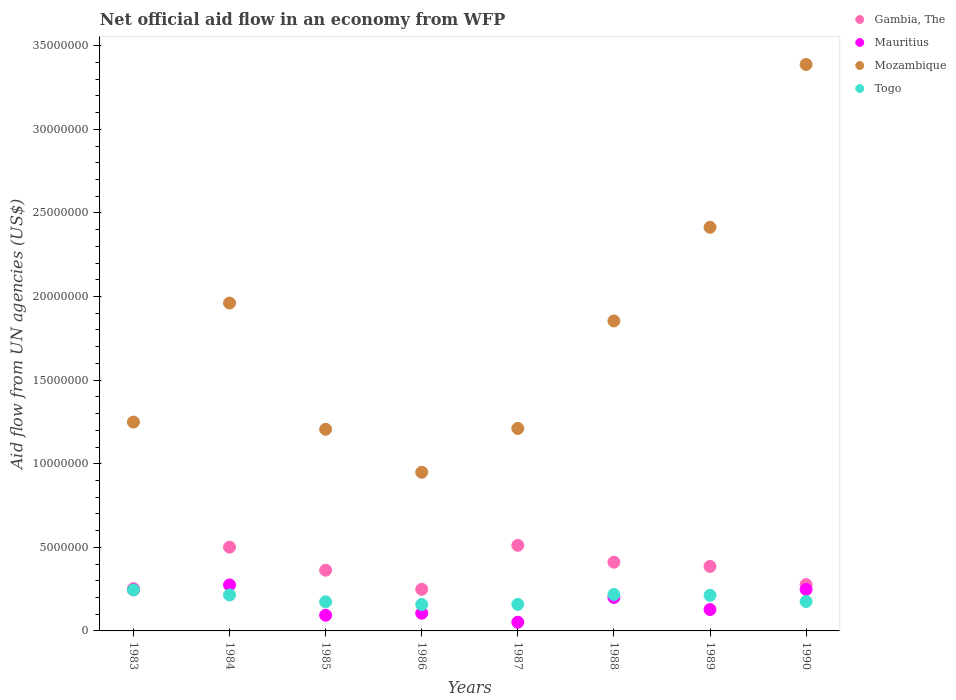What is the net official aid flow in Togo in 1988?
Your answer should be very brief. 2.18e+06. Across all years, what is the maximum net official aid flow in Togo?
Provide a short and direct response. 2.45e+06. Across all years, what is the minimum net official aid flow in Gambia, The?
Provide a short and direct response. 2.49e+06. In which year was the net official aid flow in Mozambique maximum?
Offer a very short reply. 1990. What is the total net official aid flow in Gambia, The in the graph?
Keep it short and to the point. 2.95e+07. What is the difference between the net official aid flow in Gambia, The in 1983 and that in 1987?
Provide a succinct answer. -2.59e+06. What is the difference between the net official aid flow in Gambia, The in 1988 and the net official aid flow in Mozambique in 1986?
Ensure brevity in your answer.  -5.38e+06. What is the average net official aid flow in Mauritius per year?
Give a very brief answer. 1.69e+06. In the year 1989, what is the difference between the net official aid flow in Mauritius and net official aid flow in Togo?
Your answer should be compact. -8.50e+05. What is the ratio of the net official aid flow in Gambia, The in 1983 to that in 1989?
Your answer should be very brief. 0.66. Is the net official aid flow in Mozambique in 1983 less than that in 1986?
Offer a very short reply. No. What is the difference between the highest and the lowest net official aid flow in Togo?
Your response must be concise. 8.70e+05. Is the sum of the net official aid flow in Gambia, The in 1985 and 1986 greater than the maximum net official aid flow in Togo across all years?
Your answer should be very brief. Yes. Does the net official aid flow in Togo monotonically increase over the years?
Offer a terse response. No. Are the values on the major ticks of Y-axis written in scientific E-notation?
Offer a very short reply. No. Does the graph contain grids?
Provide a short and direct response. No. Where does the legend appear in the graph?
Your answer should be compact. Top right. How many legend labels are there?
Provide a short and direct response. 4. What is the title of the graph?
Keep it short and to the point. Net official aid flow in an economy from WFP. What is the label or title of the Y-axis?
Offer a very short reply. Aid flow from UN agencies (US$). What is the Aid flow from UN agencies (US$) of Gambia, The in 1983?
Offer a terse response. 2.53e+06. What is the Aid flow from UN agencies (US$) of Mauritius in 1983?
Offer a terse response. 2.46e+06. What is the Aid flow from UN agencies (US$) of Mozambique in 1983?
Provide a short and direct response. 1.25e+07. What is the Aid flow from UN agencies (US$) of Togo in 1983?
Your response must be concise. 2.45e+06. What is the Aid flow from UN agencies (US$) in Gambia, The in 1984?
Your answer should be very brief. 5.01e+06. What is the Aid flow from UN agencies (US$) in Mauritius in 1984?
Ensure brevity in your answer.  2.75e+06. What is the Aid flow from UN agencies (US$) of Mozambique in 1984?
Your answer should be compact. 1.96e+07. What is the Aid flow from UN agencies (US$) of Togo in 1984?
Provide a short and direct response. 2.15e+06. What is the Aid flow from UN agencies (US$) of Gambia, The in 1985?
Ensure brevity in your answer.  3.63e+06. What is the Aid flow from UN agencies (US$) of Mauritius in 1985?
Provide a succinct answer. 9.40e+05. What is the Aid flow from UN agencies (US$) of Mozambique in 1985?
Your answer should be very brief. 1.21e+07. What is the Aid flow from UN agencies (US$) of Togo in 1985?
Your answer should be very brief. 1.74e+06. What is the Aid flow from UN agencies (US$) in Gambia, The in 1986?
Make the answer very short. 2.49e+06. What is the Aid flow from UN agencies (US$) of Mauritius in 1986?
Your answer should be very brief. 1.06e+06. What is the Aid flow from UN agencies (US$) in Mozambique in 1986?
Offer a very short reply. 9.49e+06. What is the Aid flow from UN agencies (US$) of Togo in 1986?
Make the answer very short. 1.58e+06. What is the Aid flow from UN agencies (US$) in Gambia, The in 1987?
Ensure brevity in your answer.  5.12e+06. What is the Aid flow from UN agencies (US$) in Mauritius in 1987?
Offer a terse response. 5.20e+05. What is the Aid flow from UN agencies (US$) in Mozambique in 1987?
Give a very brief answer. 1.21e+07. What is the Aid flow from UN agencies (US$) of Togo in 1987?
Keep it short and to the point. 1.59e+06. What is the Aid flow from UN agencies (US$) of Gambia, The in 1988?
Ensure brevity in your answer.  4.11e+06. What is the Aid flow from UN agencies (US$) of Mozambique in 1988?
Your answer should be very brief. 1.85e+07. What is the Aid flow from UN agencies (US$) in Togo in 1988?
Give a very brief answer. 2.18e+06. What is the Aid flow from UN agencies (US$) of Gambia, The in 1989?
Make the answer very short. 3.86e+06. What is the Aid flow from UN agencies (US$) of Mauritius in 1989?
Provide a short and direct response. 1.28e+06. What is the Aid flow from UN agencies (US$) in Mozambique in 1989?
Offer a very short reply. 2.41e+07. What is the Aid flow from UN agencies (US$) of Togo in 1989?
Give a very brief answer. 2.13e+06. What is the Aid flow from UN agencies (US$) in Gambia, The in 1990?
Make the answer very short. 2.77e+06. What is the Aid flow from UN agencies (US$) in Mauritius in 1990?
Provide a short and direct response. 2.48e+06. What is the Aid flow from UN agencies (US$) of Mozambique in 1990?
Provide a short and direct response. 3.39e+07. What is the Aid flow from UN agencies (US$) of Togo in 1990?
Provide a short and direct response. 1.76e+06. Across all years, what is the maximum Aid flow from UN agencies (US$) of Gambia, The?
Offer a very short reply. 5.12e+06. Across all years, what is the maximum Aid flow from UN agencies (US$) in Mauritius?
Your response must be concise. 2.75e+06. Across all years, what is the maximum Aid flow from UN agencies (US$) of Mozambique?
Make the answer very short. 3.39e+07. Across all years, what is the maximum Aid flow from UN agencies (US$) of Togo?
Provide a short and direct response. 2.45e+06. Across all years, what is the minimum Aid flow from UN agencies (US$) in Gambia, The?
Provide a succinct answer. 2.49e+06. Across all years, what is the minimum Aid flow from UN agencies (US$) in Mauritius?
Give a very brief answer. 5.20e+05. Across all years, what is the minimum Aid flow from UN agencies (US$) in Mozambique?
Give a very brief answer. 9.49e+06. Across all years, what is the minimum Aid flow from UN agencies (US$) of Togo?
Your answer should be compact. 1.58e+06. What is the total Aid flow from UN agencies (US$) in Gambia, The in the graph?
Make the answer very short. 2.95e+07. What is the total Aid flow from UN agencies (US$) in Mauritius in the graph?
Make the answer very short. 1.35e+07. What is the total Aid flow from UN agencies (US$) of Mozambique in the graph?
Offer a very short reply. 1.42e+08. What is the total Aid flow from UN agencies (US$) of Togo in the graph?
Offer a very short reply. 1.56e+07. What is the difference between the Aid flow from UN agencies (US$) of Gambia, The in 1983 and that in 1984?
Offer a terse response. -2.48e+06. What is the difference between the Aid flow from UN agencies (US$) of Mozambique in 1983 and that in 1984?
Offer a terse response. -7.12e+06. What is the difference between the Aid flow from UN agencies (US$) of Gambia, The in 1983 and that in 1985?
Offer a very short reply. -1.10e+06. What is the difference between the Aid flow from UN agencies (US$) in Mauritius in 1983 and that in 1985?
Your answer should be compact. 1.52e+06. What is the difference between the Aid flow from UN agencies (US$) of Mozambique in 1983 and that in 1985?
Give a very brief answer. 4.30e+05. What is the difference between the Aid flow from UN agencies (US$) of Togo in 1983 and that in 1985?
Provide a short and direct response. 7.10e+05. What is the difference between the Aid flow from UN agencies (US$) of Mauritius in 1983 and that in 1986?
Make the answer very short. 1.40e+06. What is the difference between the Aid flow from UN agencies (US$) of Mozambique in 1983 and that in 1986?
Give a very brief answer. 3.00e+06. What is the difference between the Aid flow from UN agencies (US$) in Togo in 1983 and that in 1986?
Your answer should be very brief. 8.70e+05. What is the difference between the Aid flow from UN agencies (US$) of Gambia, The in 1983 and that in 1987?
Your answer should be very brief. -2.59e+06. What is the difference between the Aid flow from UN agencies (US$) in Mauritius in 1983 and that in 1987?
Ensure brevity in your answer.  1.94e+06. What is the difference between the Aid flow from UN agencies (US$) in Mozambique in 1983 and that in 1987?
Offer a very short reply. 3.80e+05. What is the difference between the Aid flow from UN agencies (US$) in Togo in 1983 and that in 1987?
Make the answer very short. 8.60e+05. What is the difference between the Aid flow from UN agencies (US$) in Gambia, The in 1983 and that in 1988?
Offer a terse response. -1.58e+06. What is the difference between the Aid flow from UN agencies (US$) of Mauritius in 1983 and that in 1988?
Keep it short and to the point. 4.60e+05. What is the difference between the Aid flow from UN agencies (US$) in Mozambique in 1983 and that in 1988?
Your answer should be compact. -6.05e+06. What is the difference between the Aid flow from UN agencies (US$) in Gambia, The in 1983 and that in 1989?
Give a very brief answer. -1.33e+06. What is the difference between the Aid flow from UN agencies (US$) of Mauritius in 1983 and that in 1989?
Make the answer very short. 1.18e+06. What is the difference between the Aid flow from UN agencies (US$) in Mozambique in 1983 and that in 1989?
Offer a very short reply. -1.16e+07. What is the difference between the Aid flow from UN agencies (US$) of Togo in 1983 and that in 1989?
Your answer should be compact. 3.20e+05. What is the difference between the Aid flow from UN agencies (US$) of Gambia, The in 1983 and that in 1990?
Offer a terse response. -2.40e+05. What is the difference between the Aid flow from UN agencies (US$) of Mauritius in 1983 and that in 1990?
Make the answer very short. -2.00e+04. What is the difference between the Aid flow from UN agencies (US$) in Mozambique in 1983 and that in 1990?
Provide a short and direct response. -2.14e+07. What is the difference between the Aid flow from UN agencies (US$) in Togo in 1983 and that in 1990?
Your answer should be very brief. 6.90e+05. What is the difference between the Aid flow from UN agencies (US$) in Gambia, The in 1984 and that in 1985?
Provide a succinct answer. 1.38e+06. What is the difference between the Aid flow from UN agencies (US$) of Mauritius in 1984 and that in 1985?
Your response must be concise. 1.81e+06. What is the difference between the Aid flow from UN agencies (US$) in Mozambique in 1984 and that in 1985?
Your response must be concise. 7.55e+06. What is the difference between the Aid flow from UN agencies (US$) of Togo in 1984 and that in 1985?
Offer a terse response. 4.10e+05. What is the difference between the Aid flow from UN agencies (US$) of Gambia, The in 1984 and that in 1986?
Keep it short and to the point. 2.52e+06. What is the difference between the Aid flow from UN agencies (US$) of Mauritius in 1984 and that in 1986?
Your answer should be compact. 1.69e+06. What is the difference between the Aid flow from UN agencies (US$) in Mozambique in 1984 and that in 1986?
Make the answer very short. 1.01e+07. What is the difference between the Aid flow from UN agencies (US$) of Togo in 1984 and that in 1986?
Offer a terse response. 5.70e+05. What is the difference between the Aid flow from UN agencies (US$) of Mauritius in 1984 and that in 1987?
Provide a succinct answer. 2.23e+06. What is the difference between the Aid flow from UN agencies (US$) in Mozambique in 1984 and that in 1987?
Your answer should be very brief. 7.50e+06. What is the difference between the Aid flow from UN agencies (US$) of Togo in 1984 and that in 1987?
Provide a short and direct response. 5.60e+05. What is the difference between the Aid flow from UN agencies (US$) in Mauritius in 1984 and that in 1988?
Offer a very short reply. 7.50e+05. What is the difference between the Aid flow from UN agencies (US$) of Mozambique in 1984 and that in 1988?
Ensure brevity in your answer.  1.07e+06. What is the difference between the Aid flow from UN agencies (US$) of Gambia, The in 1984 and that in 1989?
Your response must be concise. 1.15e+06. What is the difference between the Aid flow from UN agencies (US$) of Mauritius in 1984 and that in 1989?
Make the answer very short. 1.47e+06. What is the difference between the Aid flow from UN agencies (US$) in Mozambique in 1984 and that in 1989?
Give a very brief answer. -4.53e+06. What is the difference between the Aid flow from UN agencies (US$) in Gambia, The in 1984 and that in 1990?
Give a very brief answer. 2.24e+06. What is the difference between the Aid flow from UN agencies (US$) in Mozambique in 1984 and that in 1990?
Your response must be concise. -1.43e+07. What is the difference between the Aid flow from UN agencies (US$) of Togo in 1984 and that in 1990?
Provide a succinct answer. 3.90e+05. What is the difference between the Aid flow from UN agencies (US$) in Gambia, The in 1985 and that in 1986?
Your answer should be compact. 1.14e+06. What is the difference between the Aid flow from UN agencies (US$) of Mauritius in 1985 and that in 1986?
Make the answer very short. -1.20e+05. What is the difference between the Aid flow from UN agencies (US$) of Mozambique in 1985 and that in 1986?
Make the answer very short. 2.57e+06. What is the difference between the Aid flow from UN agencies (US$) of Togo in 1985 and that in 1986?
Provide a short and direct response. 1.60e+05. What is the difference between the Aid flow from UN agencies (US$) in Gambia, The in 1985 and that in 1987?
Offer a terse response. -1.49e+06. What is the difference between the Aid flow from UN agencies (US$) in Mauritius in 1985 and that in 1987?
Ensure brevity in your answer.  4.20e+05. What is the difference between the Aid flow from UN agencies (US$) in Mozambique in 1985 and that in 1987?
Provide a succinct answer. -5.00e+04. What is the difference between the Aid flow from UN agencies (US$) in Togo in 1985 and that in 1987?
Make the answer very short. 1.50e+05. What is the difference between the Aid flow from UN agencies (US$) in Gambia, The in 1985 and that in 1988?
Your response must be concise. -4.80e+05. What is the difference between the Aid flow from UN agencies (US$) in Mauritius in 1985 and that in 1988?
Provide a succinct answer. -1.06e+06. What is the difference between the Aid flow from UN agencies (US$) in Mozambique in 1985 and that in 1988?
Provide a succinct answer. -6.48e+06. What is the difference between the Aid flow from UN agencies (US$) in Togo in 1985 and that in 1988?
Your response must be concise. -4.40e+05. What is the difference between the Aid flow from UN agencies (US$) in Gambia, The in 1985 and that in 1989?
Keep it short and to the point. -2.30e+05. What is the difference between the Aid flow from UN agencies (US$) in Mauritius in 1985 and that in 1989?
Provide a succinct answer. -3.40e+05. What is the difference between the Aid flow from UN agencies (US$) of Mozambique in 1985 and that in 1989?
Offer a terse response. -1.21e+07. What is the difference between the Aid flow from UN agencies (US$) in Togo in 1985 and that in 1989?
Provide a short and direct response. -3.90e+05. What is the difference between the Aid flow from UN agencies (US$) in Gambia, The in 1985 and that in 1990?
Offer a very short reply. 8.60e+05. What is the difference between the Aid flow from UN agencies (US$) in Mauritius in 1985 and that in 1990?
Provide a short and direct response. -1.54e+06. What is the difference between the Aid flow from UN agencies (US$) in Mozambique in 1985 and that in 1990?
Keep it short and to the point. -2.18e+07. What is the difference between the Aid flow from UN agencies (US$) in Gambia, The in 1986 and that in 1987?
Your response must be concise. -2.63e+06. What is the difference between the Aid flow from UN agencies (US$) in Mauritius in 1986 and that in 1987?
Offer a terse response. 5.40e+05. What is the difference between the Aid flow from UN agencies (US$) of Mozambique in 1986 and that in 1987?
Ensure brevity in your answer.  -2.62e+06. What is the difference between the Aid flow from UN agencies (US$) of Togo in 1986 and that in 1987?
Provide a short and direct response. -10000. What is the difference between the Aid flow from UN agencies (US$) in Gambia, The in 1986 and that in 1988?
Give a very brief answer. -1.62e+06. What is the difference between the Aid flow from UN agencies (US$) of Mauritius in 1986 and that in 1988?
Your response must be concise. -9.40e+05. What is the difference between the Aid flow from UN agencies (US$) of Mozambique in 1986 and that in 1988?
Offer a terse response. -9.05e+06. What is the difference between the Aid flow from UN agencies (US$) in Togo in 1986 and that in 1988?
Offer a terse response. -6.00e+05. What is the difference between the Aid flow from UN agencies (US$) in Gambia, The in 1986 and that in 1989?
Provide a succinct answer. -1.37e+06. What is the difference between the Aid flow from UN agencies (US$) in Mauritius in 1986 and that in 1989?
Provide a succinct answer. -2.20e+05. What is the difference between the Aid flow from UN agencies (US$) of Mozambique in 1986 and that in 1989?
Your answer should be very brief. -1.46e+07. What is the difference between the Aid flow from UN agencies (US$) of Togo in 1986 and that in 1989?
Give a very brief answer. -5.50e+05. What is the difference between the Aid flow from UN agencies (US$) of Gambia, The in 1986 and that in 1990?
Offer a terse response. -2.80e+05. What is the difference between the Aid flow from UN agencies (US$) in Mauritius in 1986 and that in 1990?
Provide a succinct answer. -1.42e+06. What is the difference between the Aid flow from UN agencies (US$) of Mozambique in 1986 and that in 1990?
Keep it short and to the point. -2.44e+07. What is the difference between the Aid flow from UN agencies (US$) of Gambia, The in 1987 and that in 1988?
Ensure brevity in your answer.  1.01e+06. What is the difference between the Aid flow from UN agencies (US$) of Mauritius in 1987 and that in 1988?
Provide a short and direct response. -1.48e+06. What is the difference between the Aid flow from UN agencies (US$) in Mozambique in 1987 and that in 1988?
Offer a terse response. -6.43e+06. What is the difference between the Aid flow from UN agencies (US$) of Togo in 1987 and that in 1988?
Offer a terse response. -5.90e+05. What is the difference between the Aid flow from UN agencies (US$) of Gambia, The in 1987 and that in 1989?
Your response must be concise. 1.26e+06. What is the difference between the Aid flow from UN agencies (US$) in Mauritius in 1987 and that in 1989?
Keep it short and to the point. -7.60e+05. What is the difference between the Aid flow from UN agencies (US$) of Mozambique in 1987 and that in 1989?
Your answer should be compact. -1.20e+07. What is the difference between the Aid flow from UN agencies (US$) in Togo in 1987 and that in 1989?
Your response must be concise. -5.40e+05. What is the difference between the Aid flow from UN agencies (US$) of Gambia, The in 1987 and that in 1990?
Keep it short and to the point. 2.35e+06. What is the difference between the Aid flow from UN agencies (US$) of Mauritius in 1987 and that in 1990?
Your answer should be very brief. -1.96e+06. What is the difference between the Aid flow from UN agencies (US$) in Mozambique in 1987 and that in 1990?
Keep it short and to the point. -2.18e+07. What is the difference between the Aid flow from UN agencies (US$) in Mauritius in 1988 and that in 1989?
Provide a short and direct response. 7.20e+05. What is the difference between the Aid flow from UN agencies (US$) of Mozambique in 1988 and that in 1989?
Your response must be concise. -5.60e+06. What is the difference between the Aid flow from UN agencies (US$) in Gambia, The in 1988 and that in 1990?
Your answer should be very brief. 1.34e+06. What is the difference between the Aid flow from UN agencies (US$) of Mauritius in 1988 and that in 1990?
Give a very brief answer. -4.80e+05. What is the difference between the Aid flow from UN agencies (US$) in Mozambique in 1988 and that in 1990?
Provide a succinct answer. -1.53e+07. What is the difference between the Aid flow from UN agencies (US$) in Gambia, The in 1989 and that in 1990?
Make the answer very short. 1.09e+06. What is the difference between the Aid flow from UN agencies (US$) in Mauritius in 1989 and that in 1990?
Give a very brief answer. -1.20e+06. What is the difference between the Aid flow from UN agencies (US$) in Mozambique in 1989 and that in 1990?
Keep it short and to the point. -9.74e+06. What is the difference between the Aid flow from UN agencies (US$) in Togo in 1989 and that in 1990?
Your answer should be very brief. 3.70e+05. What is the difference between the Aid flow from UN agencies (US$) of Gambia, The in 1983 and the Aid flow from UN agencies (US$) of Mauritius in 1984?
Keep it short and to the point. -2.20e+05. What is the difference between the Aid flow from UN agencies (US$) in Gambia, The in 1983 and the Aid flow from UN agencies (US$) in Mozambique in 1984?
Give a very brief answer. -1.71e+07. What is the difference between the Aid flow from UN agencies (US$) in Mauritius in 1983 and the Aid flow from UN agencies (US$) in Mozambique in 1984?
Your response must be concise. -1.72e+07. What is the difference between the Aid flow from UN agencies (US$) of Mauritius in 1983 and the Aid flow from UN agencies (US$) of Togo in 1984?
Ensure brevity in your answer.  3.10e+05. What is the difference between the Aid flow from UN agencies (US$) of Mozambique in 1983 and the Aid flow from UN agencies (US$) of Togo in 1984?
Your answer should be compact. 1.03e+07. What is the difference between the Aid flow from UN agencies (US$) of Gambia, The in 1983 and the Aid flow from UN agencies (US$) of Mauritius in 1985?
Give a very brief answer. 1.59e+06. What is the difference between the Aid flow from UN agencies (US$) in Gambia, The in 1983 and the Aid flow from UN agencies (US$) in Mozambique in 1985?
Provide a succinct answer. -9.53e+06. What is the difference between the Aid flow from UN agencies (US$) in Gambia, The in 1983 and the Aid flow from UN agencies (US$) in Togo in 1985?
Ensure brevity in your answer.  7.90e+05. What is the difference between the Aid flow from UN agencies (US$) of Mauritius in 1983 and the Aid flow from UN agencies (US$) of Mozambique in 1985?
Offer a very short reply. -9.60e+06. What is the difference between the Aid flow from UN agencies (US$) in Mauritius in 1983 and the Aid flow from UN agencies (US$) in Togo in 1985?
Your answer should be very brief. 7.20e+05. What is the difference between the Aid flow from UN agencies (US$) in Mozambique in 1983 and the Aid flow from UN agencies (US$) in Togo in 1985?
Offer a very short reply. 1.08e+07. What is the difference between the Aid flow from UN agencies (US$) of Gambia, The in 1983 and the Aid flow from UN agencies (US$) of Mauritius in 1986?
Give a very brief answer. 1.47e+06. What is the difference between the Aid flow from UN agencies (US$) of Gambia, The in 1983 and the Aid flow from UN agencies (US$) of Mozambique in 1986?
Give a very brief answer. -6.96e+06. What is the difference between the Aid flow from UN agencies (US$) in Gambia, The in 1983 and the Aid flow from UN agencies (US$) in Togo in 1986?
Make the answer very short. 9.50e+05. What is the difference between the Aid flow from UN agencies (US$) of Mauritius in 1983 and the Aid flow from UN agencies (US$) of Mozambique in 1986?
Provide a short and direct response. -7.03e+06. What is the difference between the Aid flow from UN agencies (US$) in Mauritius in 1983 and the Aid flow from UN agencies (US$) in Togo in 1986?
Make the answer very short. 8.80e+05. What is the difference between the Aid flow from UN agencies (US$) of Mozambique in 1983 and the Aid flow from UN agencies (US$) of Togo in 1986?
Offer a very short reply. 1.09e+07. What is the difference between the Aid flow from UN agencies (US$) in Gambia, The in 1983 and the Aid flow from UN agencies (US$) in Mauritius in 1987?
Your answer should be very brief. 2.01e+06. What is the difference between the Aid flow from UN agencies (US$) in Gambia, The in 1983 and the Aid flow from UN agencies (US$) in Mozambique in 1987?
Keep it short and to the point. -9.58e+06. What is the difference between the Aid flow from UN agencies (US$) of Gambia, The in 1983 and the Aid flow from UN agencies (US$) of Togo in 1987?
Provide a succinct answer. 9.40e+05. What is the difference between the Aid flow from UN agencies (US$) in Mauritius in 1983 and the Aid flow from UN agencies (US$) in Mozambique in 1987?
Your answer should be compact. -9.65e+06. What is the difference between the Aid flow from UN agencies (US$) of Mauritius in 1983 and the Aid flow from UN agencies (US$) of Togo in 1987?
Offer a terse response. 8.70e+05. What is the difference between the Aid flow from UN agencies (US$) of Mozambique in 1983 and the Aid flow from UN agencies (US$) of Togo in 1987?
Offer a terse response. 1.09e+07. What is the difference between the Aid flow from UN agencies (US$) in Gambia, The in 1983 and the Aid flow from UN agencies (US$) in Mauritius in 1988?
Make the answer very short. 5.30e+05. What is the difference between the Aid flow from UN agencies (US$) of Gambia, The in 1983 and the Aid flow from UN agencies (US$) of Mozambique in 1988?
Your response must be concise. -1.60e+07. What is the difference between the Aid flow from UN agencies (US$) in Mauritius in 1983 and the Aid flow from UN agencies (US$) in Mozambique in 1988?
Offer a very short reply. -1.61e+07. What is the difference between the Aid flow from UN agencies (US$) in Mauritius in 1983 and the Aid flow from UN agencies (US$) in Togo in 1988?
Offer a very short reply. 2.80e+05. What is the difference between the Aid flow from UN agencies (US$) in Mozambique in 1983 and the Aid flow from UN agencies (US$) in Togo in 1988?
Offer a very short reply. 1.03e+07. What is the difference between the Aid flow from UN agencies (US$) in Gambia, The in 1983 and the Aid flow from UN agencies (US$) in Mauritius in 1989?
Give a very brief answer. 1.25e+06. What is the difference between the Aid flow from UN agencies (US$) in Gambia, The in 1983 and the Aid flow from UN agencies (US$) in Mozambique in 1989?
Your answer should be compact. -2.16e+07. What is the difference between the Aid flow from UN agencies (US$) in Gambia, The in 1983 and the Aid flow from UN agencies (US$) in Togo in 1989?
Your answer should be very brief. 4.00e+05. What is the difference between the Aid flow from UN agencies (US$) in Mauritius in 1983 and the Aid flow from UN agencies (US$) in Mozambique in 1989?
Offer a terse response. -2.17e+07. What is the difference between the Aid flow from UN agencies (US$) in Mozambique in 1983 and the Aid flow from UN agencies (US$) in Togo in 1989?
Provide a short and direct response. 1.04e+07. What is the difference between the Aid flow from UN agencies (US$) in Gambia, The in 1983 and the Aid flow from UN agencies (US$) in Mozambique in 1990?
Your answer should be very brief. -3.14e+07. What is the difference between the Aid flow from UN agencies (US$) of Gambia, The in 1983 and the Aid flow from UN agencies (US$) of Togo in 1990?
Offer a terse response. 7.70e+05. What is the difference between the Aid flow from UN agencies (US$) of Mauritius in 1983 and the Aid flow from UN agencies (US$) of Mozambique in 1990?
Provide a short and direct response. -3.14e+07. What is the difference between the Aid flow from UN agencies (US$) of Mauritius in 1983 and the Aid flow from UN agencies (US$) of Togo in 1990?
Provide a succinct answer. 7.00e+05. What is the difference between the Aid flow from UN agencies (US$) in Mozambique in 1983 and the Aid flow from UN agencies (US$) in Togo in 1990?
Offer a very short reply. 1.07e+07. What is the difference between the Aid flow from UN agencies (US$) of Gambia, The in 1984 and the Aid flow from UN agencies (US$) of Mauritius in 1985?
Provide a succinct answer. 4.07e+06. What is the difference between the Aid flow from UN agencies (US$) of Gambia, The in 1984 and the Aid flow from UN agencies (US$) of Mozambique in 1985?
Offer a very short reply. -7.05e+06. What is the difference between the Aid flow from UN agencies (US$) of Gambia, The in 1984 and the Aid flow from UN agencies (US$) of Togo in 1985?
Offer a very short reply. 3.27e+06. What is the difference between the Aid flow from UN agencies (US$) of Mauritius in 1984 and the Aid flow from UN agencies (US$) of Mozambique in 1985?
Keep it short and to the point. -9.31e+06. What is the difference between the Aid flow from UN agencies (US$) of Mauritius in 1984 and the Aid flow from UN agencies (US$) of Togo in 1985?
Ensure brevity in your answer.  1.01e+06. What is the difference between the Aid flow from UN agencies (US$) of Mozambique in 1984 and the Aid flow from UN agencies (US$) of Togo in 1985?
Offer a very short reply. 1.79e+07. What is the difference between the Aid flow from UN agencies (US$) of Gambia, The in 1984 and the Aid flow from UN agencies (US$) of Mauritius in 1986?
Offer a very short reply. 3.95e+06. What is the difference between the Aid flow from UN agencies (US$) in Gambia, The in 1984 and the Aid flow from UN agencies (US$) in Mozambique in 1986?
Offer a very short reply. -4.48e+06. What is the difference between the Aid flow from UN agencies (US$) of Gambia, The in 1984 and the Aid flow from UN agencies (US$) of Togo in 1986?
Make the answer very short. 3.43e+06. What is the difference between the Aid flow from UN agencies (US$) in Mauritius in 1984 and the Aid flow from UN agencies (US$) in Mozambique in 1986?
Give a very brief answer. -6.74e+06. What is the difference between the Aid flow from UN agencies (US$) of Mauritius in 1984 and the Aid flow from UN agencies (US$) of Togo in 1986?
Provide a succinct answer. 1.17e+06. What is the difference between the Aid flow from UN agencies (US$) of Mozambique in 1984 and the Aid flow from UN agencies (US$) of Togo in 1986?
Provide a succinct answer. 1.80e+07. What is the difference between the Aid flow from UN agencies (US$) of Gambia, The in 1984 and the Aid flow from UN agencies (US$) of Mauritius in 1987?
Offer a terse response. 4.49e+06. What is the difference between the Aid flow from UN agencies (US$) of Gambia, The in 1984 and the Aid flow from UN agencies (US$) of Mozambique in 1987?
Your response must be concise. -7.10e+06. What is the difference between the Aid flow from UN agencies (US$) of Gambia, The in 1984 and the Aid flow from UN agencies (US$) of Togo in 1987?
Provide a succinct answer. 3.42e+06. What is the difference between the Aid flow from UN agencies (US$) in Mauritius in 1984 and the Aid flow from UN agencies (US$) in Mozambique in 1987?
Offer a very short reply. -9.36e+06. What is the difference between the Aid flow from UN agencies (US$) of Mauritius in 1984 and the Aid flow from UN agencies (US$) of Togo in 1987?
Provide a succinct answer. 1.16e+06. What is the difference between the Aid flow from UN agencies (US$) in Mozambique in 1984 and the Aid flow from UN agencies (US$) in Togo in 1987?
Offer a terse response. 1.80e+07. What is the difference between the Aid flow from UN agencies (US$) in Gambia, The in 1984 and the Aid flow from UN agencies (US$) in Mauritius in 1988?
Your answer should be compact. 3.01e+06. What is the difference between the Aid flow from UN agencies (US$) in Gambia, The in 1984 and the Aid flow from UN agencies (US$) in Mozambique in 1988?
Ensure brevity in your answer.  -1.35e+07. What is the difference between the Aid flow from UN agencies (US$) of Gambia, The in 1984 and the Aid flow from UN agencies (US$) of Togo in 1988?
Keep it short and to the point. 2.83e+06. What is the difference between the Aid flow from UN agencies (US$) in Mauritius in 1984 and the Aid flow from UN agencies (US$) in Mozambique in 1988?
Your answer should be very brief. -1.58e+07. What is the difference between the Aid flow from UN agencies (US$) in Mauritius in 1984 and the Aid flow from UN agencies (US$) in Togo in 1988?
Your answer should be very brief. 5.70e+05. What is the difference between the Aid flow from UN agencies (US$) in Mozambique in 1984 and the Aid flow from UN agencies (US$) in Togo in 1988?
Your answer should be very brief. 1.74e+07. What is the difference between the Aid flow from UN agencies (US$) of Gambia, The in 1984 and the Aid flow from UN agencies (US$) of Mauritius in 1989?
Offer a terse response. 3.73e+06. What is the difference between the Aid flow from UN agencies (US$) in Gambia, The in 1984 and the Aid flow from UN agencies (US$) in Mozambique in 1989?
Your response must be concise. -1.91e+07. What is the difference between the Aid flow from UN agencies (US$) of Gambia, The in 1984 and the Aid flow from UN agencies (US$) of Togo in 1989?
Ensure brevity in your answer.  2.88e+06. What is the difference between the Aid flow from UN agencies (US$) of Mauritius in 1984 and the Aid flow from UN agencies (US$) of Mozambique in 1989?
Provide a succinct answer. -2.14e+07. What is the difference between the Aid flow from UN agencies (US$) of Mauritius in 1984 and the Aid flow from UN agencies (US$) of Togo in 1989?
Provide a succinct answer. 6.20e+05. What is the difference between the Aid flow from UN agencies (US$) of Mozambique in 1984 and the Aid flow from UN agencies (US$) of Togo in 1989?
Make the answer very short. 1.75e+07. What is the difference between the Aid flow from UN agencies (US$) of Gambia, The in 1984 and the Aid flow from UN agencies (US$) of Mauritius in 1990?
Provide a short and direct response. 2.53e+06. What is the difference between the Aid flow from UN agencies (US$) of Gambia, The in 1984 and the Aid flow from UN agencies (US$) of Mozambique in 1990?
Ensure brevity in your answer.  -2.89e+07. What is the difference between the Aid flow from UN agencies (US$) in Gambia, The in 1984 and the Aid flow from UN agencies (US$) in Togo in 1990?
Offer a very short reply. 3.25e+06. What is the difference between the Aid flow from UN agencies (US$) in Mauritius in 1984 and the Aid flow from UN agencies (US$) in Mozambique in 1990?
Your response must be concise. -3.11e+07. What is the difference between the Aid flow from UN agencies (US$) of Mauritius in 1984 and the Aid flow from UN agencies (US$) of Togo in 1990?
Your answer should be compact. 9.90e+05. What is the difference between the Aid flow from UN agencies (US$) in Mozambique in 1984 and the Aid flow from UN agencies (US$) in Togo in 1990?
Provide a succinct answer. 1.78e+07. What is the difference between the Aid flow from UN agencies (US$) in Gambia, The in 1985 and the Aid flow from UN agencies (US$) in Mauritius in 1986?
Your response must be concise. 2.57e+06. What is the difference between the Aid flow from UN agencies (US$) of Gambia, The in 1985 and the Aid flow from UN agencies (US$) of Mozambique in 1986?
Provide a short and direct response. -5.86e+06. What is the difference between the Aid flow from UN agencies (US$) in Gambia, The in 1985 and the Aid flow from UN agencies (US$) in Togo in 1986?
Give a very brief answer. 2.05e+06. What is the difference between the Aid flow from UN agencies (US$) of Mauritius in 1985 and the Aid flow from UN agencies (US$) of Mozambique in 1986?
Your answer should be compact. -8.55e+06. What is the difference between the Aid flow from UN agencies (US$) of Mauritius in 1985 and the Aid flow from UN agencies (US$) of Togo in 1986?
Keep it short and to the point. -6.40e+05. What is the difference between the Aid flow from UN agencies (US$) in Mozambique in 1985 and the Aid flow from UN agencies (US$) in Togo in 1986?
Provide a succinct answer. 1.05e+07. What is the difference between the Aid flow from UN agencies (US$) in Gambia, The in 1985 and the Aid flow from UN agencies (US$) in Mauritius in 1987?
Provide a short and direct response. 3.11e+06. What is the difference between the Aid flow from UN agencies (US$) in Gambia, The in 1985 and the Aid flow from UN agencies (US$) in Mozambique in 1987?
Offer a terse response. -8.48e+06. What is the difference between the Aid flow from UN agencies (US$) in Gambia, The in 1985 and the Aid flow from UN agencies (US$) in Togo in 1987?
Offer a terse response. 2.04e+06. What is the difference between the Aid flow from UN agencies (US$) of Mauritius in 1985 and the Aid flow from UN agencies (US$) of Mozambique in 1987?
Offer a very short reply. -1.12e+07. What is the difference between the Aid flow from UN agencies (US$) in Mauritius in 1985 and the Aid flow from UN agencies (US$) in Togo in 1987?
Provide a succinct answer. -6.50e+05. What is the difference between the Aid flow from UN agencies (US$) of Mozambique in 1985 and the Aid flow from UN agencies (US$) of Togo in 1987?
Offer a terse response. 1.05e+07. What is the difference between the Aid flow from UN agencies (US$) in Gambia, The in 1985 and the Aid flow from UN agencies (US$) in Mauritius in 1988?
Keep it short and to the point. 1.63e+06. What is the difference between the Aid flow from UN agencies (US$) of Gambia, The in 1985 and the Aid flow from UN agencies (US$) of Mozambique in 1988?
Make the answer very short. -1.49e+07. What is the difference between the Aid flow from UN agencies (US$) in Gambia, The in 1985 and the Aid flow from UN agencies (US$) in Togo in 1988?
Keep it short and to the point. 1.45e+06. What is the difference between the Aid flow from UN agencies (US$) in Mauritius in 1985 and the Aid flow from UN agencies (US$) in Mozambique in 1988?
Provide a short and direct response. -1.76e+07. What is the difference between the Aid flow from UN agencies (US$) of Mauritius in 1985 and the Aid flow from UN agencies (US$) of Togo in 1988?
Your answer should be compact. -1.24e+06. What is the difference between the Aid flow from UN agencies (US$) of Mozambique in 1985 and the Aid flow from UN agencies (US$) of Togo in 1988?
Your response must be concise. 9.88e+06. What is the difference between the Aid flow from UN agencies (US$) of Gambia, The in 1985 and the Aid flow from UN agencies (US$) of Mauritius in 1989?
Provide a succinct answer. 2.35e+06. What is the difference between the Aid flow from UN agencies (US$) in Gambia, The in 1985 and the Aid flow from UN agencies (US$) in Mozambique in 1989?
Keep it short and to the point. -2.05e+07. What is the difference between the Aid flow from UN agencies (US$) in Gambia, The in 1985 and the Aid flow from UN agencies (US$) in Togo in 1989?
Provide a short and direct response. 1.50e+06. What is the difference between the Aid flow from UN agencies (US$) in Mauritius in 1985 and the Aid flow from UN agencies (US$) in Mozambique in 1989?
Your response must be concise. -2.32e+07. What is the difference between the Aid flow from UN agencies (US$) in Mauritius in 1985 and the Aid flow from UN agencies (US$) in Togo in 1989?
Ensure brevity in your answer.  -1.19e+06. What is the difference between the Aid flow from UN agencies (US$) of Mozambique in 1985 and the Aid flow from UN agencies (US$) of Togo in 1989?
Your response must be concise. 9.93e+06. What is the difference between the Aid flow from UN agencies (US$) in Gambia, The in 1985 and the Aid flow from UN agencies (US$) in Mauritius in 1990?
Your answer should be compact. 1.15e+06. What is the difference between the Aid flow from UN agencies (US$) of Gambia, The in 1985 and the Aid flow from UN agencies (US$) of Mozambique in 1990?
Offer a very short reply. -3.02e+07. What is the difference between the Aid flow from UN agencies (US$) in Gambia, The in 1985 and the Aid flow from UN agencies (US$) in Togo in 1990?
Ensure brevity in your answer.  1.87e+06. What is the difference between the Aid flow from UN agencies (US$) in Mauritius in 1985 and the Aid flow from UN agencies (US$) in Mozambique in 1990?
Ensure brevity in your answer.  -3.29e+07. What is the difference between the Aid flow from UN agencies (US$) of Mauritius in 1985 and the Aid flow from UN agencies (US$) of Togo in 1990?
Your response must be concise. -8.20e+05. What is the difference between the Aid flow from UN agencies (US$) of Mozambique in 1985 and the Aid flow from UN agencies (US$) of Togo in 1990?
Make the answer very short. 1.03e+07. What is the difference between the Aid flow from UN agencies (US$) of Gambia, The in 1986 and the Aid flow from UN agencies (US$) of Mauritius in 1987?
Your answer should be very brief. 1.97e+06. What is the difference between the Aid flow from UN agencies (US$) in Gambia, The in 1986 and the Aid flow from UN agencies (US$) in Mozambique in 1987?
Your answer should be very brief. -9.62e+06. What is the difference between the Aid flow from UN agencies (US$) of Gambia, The in 1986 and the Aid flow from UN agencies (US$) of Togo in 1987?
Offer a very short reply. 9.00e+05. What is the difference between the Aid flow from UN agencies (US$) of Mauritius in 1986 and the Aid flow from UN agencies (US$) of Mozambique in 1987?
Ensure brevity in your answer.  -1.10e+07. What is the difference between the Aid flow from UN agencies (US$) in Mauritius in 1986 and the Aid flow from UN agencies (US$) in Togo in 1987?
Offer a terse response. -5.30e+05. What is the difference between the Aid flow from UN agencies (US$) of Mozambique in 1986 and the Aid flow from UN agencies (US$) of Togo in 1987?
Provide a short and direct response. 7.90e+06. What is the difference between the Aid flow from UN agencies (US$) in Gambia, The in 1986 and the Aid flow from UN agencies (US$) in Mozambique in 1988?
Your answer should be very brief. -1.60e+07. What is the difference between the Aid flow from UN agencies (US$) in Mauritius in 1986 and the Aid flow from UN agencies (US$) in Mozambique in 1988?
Offer a terse response. -1.75e+07. What is the difference between the Aid flow from UN agencies (US$) of Mauritius in 1986 and the Aid flow from UN agencies (US$) of Togo in 1988?
Ensure brevity in your answer.  -1.12e+06. What is the difference between the Aid flow from UN agencies (US$) in Mozambique in 1986 and the Aid flow from UN agencies (US$) in Togo in 1988?
Give a very brief answer. 7.31e+06. What is the difference between the Aid flow from UN agencies (US$) of Gambia, The in 1986 and the Aid flow from UN agencies (US$) of Mauritius in 1989?
Ensure brevity in your answer.  1.21e+06. What is the difference between the Aid flow from UN agencies (US$) in Gambia, The in 1986 and the Aid flow from UN agencies (US$) in Mozambique in 1989?
Make the answer very short. -2.16e+07. What is the difference between the Aid flow from UN agencies (US$) of Gambia, The in 1986 and the Aid flow from UN agencies (US$) of Togo in 1989?
Make the answer very short. 3.60e+05. What is the difference between the Aid flow from UN agencies (US$) in Mauritius in 1986 and the Aid flow from UN agencies (US$) in Mozambique in 1989?
Make the answer very short. -2.31e+07. What is the difference between the Aid flow from UN agencies (US$) of Mauritius in 1986 and the Aid flow from UN agencies (US$) of Togo in 1989?
Give a very brief answer. -1.07e+06. What is the difference between the Aid flow from UN agencies (US$) in Mozambique in 1986 and the Aid flow from UN agencies (US$) in Togo in 1989?
Give a very brief answer. 7.36e+06. What is the difference between the Aid flow from UN agencies (US$) of Gambia, The in 1986 and the Aid flow from UN agencies (US$) of Mozambique in 1990?
Ensure brevity in your answer.  -3.14e+07. What is the difference between the Aid flow from UN agencies (US$) in Gambia, The in 1986 and the Aid flow from UN agencies (US$) in Togo in 1990?
Ensure brevity in your answer.  7.30e+05. What is the difference between the Aid flow from UN agencies (US$) in Mauritius in 1986 and the Aid flow from UN agencies (US$) in Mozambique in 1990?
Offer a very short reply. -3.28e+07. What is the difference between the Aid flow from UN agencies (US$) of Mauritius in 1986 and the Aid flow from UN agencies (US$) of Togo in 1990?
Provide a short and direct response. -7.00e+05. What is the difference between the Aid flow from UN agencies (US$) in Mozambique in 1986 and the Aid flow from UN agencies (US$) in Togo in 1990?
Offer a terse response. 7.73e+06. What is the difference between the Aid flow from UN agencies (US$) in Gambia, The in 1987 and the Aid flow from UN agencies (US$) in Mauritius in 1988?
Your response must be concise. 3.12e+06. What is the difference between the Aid flow from UN agencies (US$) in Gambia, The in 1987 and the Aid flow from UN agencies (US$) in Mozambique in 1988?
Ensure brevity in your answer.  -1.34e+07. What is the difference between the Aid flow from UN agencies (US$) of Gambia, The in 1987 and the Aid flow from UN agencies (US$) of Togo in 1988?
Your answer should be compact. 2.94e+06. What is the difference between the Aid flow from UN agencies (US$) in Mauritius in 1987 and the Aid flow from UN agencies (US$) in Mozambique in 1988?
Your response must be concise. -1.80e+07. What is the difference between the Aid flow from UN agencies (US$) in Mauritius in 1987 and the Aid flow from UN agencies (US$) in Togo in 1988?
Your answer should be compact. -1.66e+06. What is the difference between the Aid flow from UN agencies (US$) in Mozambique in 1987 and the Aid flow from UN agencies (US$) in Togo in 1988?
Offer a terse response. 9.93e+06. What is the difference between the Aid flow from UN agencies (US$) of Gambia, The in 1987 and the Aid flow from UN agencies (US$) of Mauritius in 1989?
Your response must be concise. 3.84e+06. What is the difference between the Aid flow from UN agencies (US$) of Gambia, The in 1987 and the Aid flow from UN agencies (US$) of Mozambique in 1989?
Your answer should be compact. -1.90e+07. What is the difference between the Aid flow from UN agencies (US$) in Gambia, The in 1987 and the Aid flow from UN agencies (US$) in Togo in 1989?
Your answer should be compact. 2.99e+06. What is the difference between the Aid flow from UN agencies (US$) of Mauritius in 1987 and the Aid flow from UN agencies (US$) of Mozambique in 1989?
Provide a short and direct response. -2.36e+07. What is the difference between the Aid flow from UN agencies (US$) of Mauritius in 1987 and the Aid flow from UN agencies (US$) of Togo in 1989?
Your response must be concise. -1.61e+06. What is the difference between the Aid flow from UN agencies (US$) in Mozambique in 1987 and the Aid flow from UN agencies (US$) in Togo in 1989?
Your response must be concise. 9.98e+06. What is the difference between the Aid flow from UN agencies (US$) in Gambia, The in 1987 and the Aid flow from UN agencies (US$) in Mauritius in 1990?
Offer a very short reply. 2.64e+06. What is the difference between the Aid flow from UN agencies (US$) of Gambia, The in 1987 and the Aid flow from UN agencies (US$) of Mozambique in 1990?
Keep it short and to the point. -2.88e+07. What is the difference between the Aid flow from UN agencies (US$) in Gambia, The in 1987 and the Aid flow from UN agencies (US$) in Togo in 1990?
Offer a terse response. 3.36e+06. What is the difference between the Aid flow from UN agencies (US$) of Mauritius in 1987 and the Aid flow from UN agencies (US$) of Mozambique in 1990?
Your response must be concise. -3.34e+07. What is the difference between the Aid flow from UN agencies (US$) in Mauritius in 1987 and the Aid flow from UN agencies (US$) in Togo in 1990?
Your answer should be compact. -1.24e+06. What is the difference between the Aid flow from UN agencies (US$) of Mozambique in 1987 and the Aid flow from UN agencies (US$) of Togo in 1990?
Your response must be concise. 1.04e+07. What is the difference between the Aid flow from UN agencies (US$) in Gambia, The in 1988 and the Aid flow from UN agencies (US$) in Mauritius in 1989?
Ensure brevity in your answer.  2.83e+06. What is the difference between the Aid flow from UN agencies (US$) of Gambia, The in 1988 and the Aid flow from UN agencies (US$) of Mozambique in 1989?
Provide a succinct answer. -2.00e+07. What is the difference between the Aid flow from UN agencies (US$) of Gambia, The in 1988 and the Aid flow from UN agencies (US$) of Togo in 1989?
Make the answer very short. 1.98e+06. What is the difference between the Aid flow from UN agencies (US$) of Mauritius in 1988 and the Aid flow from UN agencies (US$) of Mozambique in 1989?
Your response must be concise. -2.21e+07. What is the difference between the Aid flow from UN agencies (US$) in Mozambique in 1988 and the Aid flow from UN agencies (US$) in Togo in 1989?
Your response must be concise. 1.64e+07. What is the difference between the Aid flow from UN agencies (US$) in Gambia, The in 1988 and the Aid flow from UN agencies (US$) in Mauritius in 1990?
Give a very brief answer. 1.63e+06. What is the difference between the Aid flow from UN agencies (US$) of Gambia, The in 1988 and the Aid flow from UN agencies (US$) of Mozambique in 1990?
Offer a very short reply. -2.98e+07. What is the difference between the Aid flow from UN agencies (US$) of Gambia, The in 1988 and the Aid flow from UN agencies (US$) of Togo in 1990?
Give a very brief answer. 2.35e+06. What is the difference between the Aid flow from UN agencies (US$) in Mauritius in 1988 and the Aid flow from UN agencies (US$) in Mozambique in 1990?
Your answer should be compact. -3.19e+07. What is the difference between the Aid flow from UN agencies (US$) of Mauritius in 1988 and the Aid flow from UN agencies (US$) of Togo in 1990?
Offer a terse response. 2.40e+05. What is the difference between the Aid flow from UN agencies (US$) in Mozambique in 1988 and the Aid flow from UN agencies (US$) in Togo in 1990?
Offer a terse response. 1.68e+07. What is the difference between the Aid flow from UN agencies (US$) in Gambia, The in 1989 and the Aid flow from UN agencies (US$) in Mauritius in 1990?
Make the answer very short. 1.38e+06. What is the difference between the Aid flow from UN agencies (US$) of Gambia, The in 1989 and the Aid flow from UN agencies (US$) of Mozambique in 1990?
Your answer should be compact. -3.00e+07. What is the difference between the Aid flow from UN agencies (US$) of Gambia, The in 1989 and the Aid flow from UN agencies (US$) of Togo in 1990?
Provide a succinct answer. 2.10e+06. What is the difference between the Aid flow from UN agencies (US$) of Mauritius in 1989 and the Aid flow from UN agencies (US$) of Mozambique in 1990?
Provide a short and direct response. -3.26e+07. What is the difference between the Aid flow from UN agencies (US$) of Mauritius in 1989 and the Aid flow from UN agencies (US$) of Togo in 1990?
Offer a terse response. -4.80e+05. What is the difference between the Aid flow from UN agencies (US$) of Mozambique in 1989 and the Aid flow from UN agencies (US$) of Togo in 1990?
Provide a succinct answer. 2.24e+07. What is the average Aid flow from UN agencies (US$) in Gambia, The per year?
Your answer should be compact. 3.69e+06. What is the average Aid flow from UN agencies (US$) of Mauritius per year?
Provide a short and direct response. 1.69e+06. What is the average Aid flow from UN agencies (US$) of Mozambique per year?
Keep it short and to the point. 1.78e+07. What is the average Aid flow from UN agencies (US$) of Togo per year?
Your answer should be compact. 1.95e+06. In the year 1983, what is the difference between the Aid flow from UN agencies (US$) of Gambia, The and Aid flow from UN agencies (US$) of Mozambique?
Offer a terse response. -9.96e+06. In the year 1983, what is the difference between the Aid flow from UN agencies (US$) in Gambia, The and Aid flow from UN agencies (US$) in Togo?
Provide a short and direct response. 8.00e+04. In the year 1983, what is the difference between the Aid flow from UN agencies (US$) in Mauritius and Aid flow from UN agencies (US$) in Mozambique?
Give a very brief answer. -1.00e+07. In the year 1983, what is the difference between the Aid flow from UN agencies (US$) of Mauritius and Aid flow from UN agencies (US$) of Togo?
Offer a terse response. 10000. In the year 1983, what is the difference between the Aid flow from UN agencies (US$) in Mozambique and Aid flow from UN agencies (US$) in Togo?
Give a very brief answer. 1.00e+07. In the year 1984, what is the difference between the Aid flow from UN agencies (US$) in Gambia, The and Aid flow from UN agencies (US$) in Mauritius?
Your response must be concise. 2.26e+06. In the year 1984, what is the difference between the Aid flow from UN agencies (US$) of Gambia, The and Aid flow from UN agencies (US$) of Mozambique?
Your answer should be very brief. -1.46e+07. In the year 1984, what is the difference between the Aid flow from UN agencies (US$) of Gambia, The and Aid flow from UN agencies (US$) of Togo?
Keep it short and to the point. 2.86e+06. In the year 1984, what is the difference between the Aid flow from UN agencies (US$) of Mauritius and Aid flow from UN agencies (US$) of Mozambique?
Ensure brevity in your answer.  -1.69e+07. In the year 1984, what is the difference between the Aid flow from UN agencies (US$) of Mauritius and Aid flow from UN agencies (US$) of Togo?
Make the answer very short. 6.00e+05. In the year 1984, what is the difference between the Aid flow from UN agencies (US$) in Mozambique and Aid flow from UN agencies (US$) in Togo?
Make the answer very short. 1.75e+07. In the year 1985, what is the difference between the Aid flow from UN agencies (US$) in Gambia, The and Aid flow from UN agencies (US$) in Mauritius?
Give a very brief answer. 2.69e+06. In the year 1985, what is the difference between the Aid flow from UN agencies (US$) of Gambia, The and Aid flow from UN agencies (US$) of Mozambique?
Provide a succinct answer. -8.43e+06. In the year 1985, what is the difference between the Aid flow from UN agencies (US$) in Gambia, The and Aid flow from UN agencies (US$) in Togo?
Make the answer very short. 1.89e+06. In the year 1985, what is the difference between the Aid flow from UN agencies (US$) in Mauritius and Aid flow from UN agencies (US$) in Mozambique?
Make the answer very short. -1.11e+07. In the year 1985, what is the difference between the Aid flow from UN agencies (US$) in Mauritius and Aid flow from UN agencies (US$) in Togo?
Make the answer very short. -8.00e+05. In the year 1985, what is the difference between the Aid flow from UN agencies (US$) of Mozambique and Aid flow from UN agencies (US$) of Togo?
Give a very brief answer. 1.03e+07. In the year 1986, what is the difference between the Aid flow from UN agencies (US$) in Gambia, The and Aid flow from UN agencies (US$) in Mauritius?
Ensure brevity in your answer.  1.43e+06. In the year 1986, what is the difference between the Aid flow from UN agencies (US$) of Gambia, The and Aid flow from UN agencies (US$) of Mozambique?
Offer a very short reply. -7.00e+06. In the year 1986, what is the difference between the Aid flow from UN agencies (US$) in Gambia, The and Aid flow from UN agencies (US$) in Togo?
Your response must be concise. 9.10e+05. In the year 1986, what is the difference between the Aid flow from UN agencies (US$) in Mauritius and Aid flow from UN agencies (US$) in Mozambique?
Keep it short and to the point. -8.43e+06. In the year 1986, what is the difference between the Aid flow from UN agencies (US$) of Mauritius and Aid flow from UN agencies (US$) of Togo?
Provide a succinct answer. -5.20e+05. In the year 1986, what is the difference between the Aid flow from UN agencies (US$) in Mozambique and Aid flow from UN agencies (US$) in Togo?
Ensure brevity in your answer.  7.91e+06. In the year 1987, what is the difference between the Aid flow from UN agencies (US$) of Gambia, The and Aid flow from UN agencies (US$) of Mauritius?
Your response must be concise. 4.60e+06. In the year 1987, what is the difference between the Aid flow from UN agencies (US$) of Gambia, The and Aid flow from UN agencies (US$) of Mozambique?
Your response must be concise. -6.99e+06. In the year 1987, what is the difference between the Aid flow from UN agencies (US$) of Gambia, The and Aid flow from UN agencies (US$) of Togo?
Provide a short and direct response. 3.53e+06. In the year 1987, what is the difference between the Aid flow from UN agencies (US$) of Mauritius and Aid flow from UN agencies (US$) of Mozambique?
Offer a very short reply. -1.16e+07. In the year 1987, what is the difference between the Aid flow from UN agencies (US$) of Mauritius and Aid flow from UN agencies (US$) of Togo?
Provide a short and direct response. -1.07e+06. In the year 1987, what is the difference between the Aid flow from UN agencies (US$) of Mozambique and Aid flow from UN agencies (US$) of Togo?
Offer a terse response. 1.05e+07. In the year 1988, what is the difference between the Aid flow from UN agencies (US$) in Gambia, The and Aid flow from UN agencies (US$) in Mauritius?
Make the answer very short. 2.11e+06. In the year 1988, what is the difference between the Aid flow from UN agencies (US$) of Gambia, The and Aid flow from UN agencies (US$) of Mozambique?
Provide a short and direct response. -1.44e+07. In the year 1988, what is the difference between the Aid flow from UN agencies (US$) of Gambia, The and Aid flow from UN agencies (US$) of Togo?
Keep it short and to the point. 1.93e+06. In the year 1988, what is the difference between the Aid flow from UN agencies (US$) in Mauritius and Aid flow from UN agencies (US$) in Mozambique?
Offer a very short reply. -1.65e+07. In the year 1988, what is the difference between the Aid flow from UN agencies (US$) in Mozambique and Aid flow from UN agencies (US$) in Togo?
Keep it short and to the point. 1.64e+07. In the year 1989, what is the difference between the Aid flow from UN agencies (US$) of Gambia, The and Aid flow from UN agencies (US$) of Mauritius?
Offer a very short reply. 2.58e+06. In the year 1989, what is the difference between the Aid flow from UN agencies (US$) in Gambia, The and Aid flow from UN agencies (US$) in Mozambique?
Ensure brevity in your answer.  -2.03e+07. In the year 1989, what is the difference between the Aid flow from UN agencies (US$) of Gambia, The and Aid flow from UN agencies (US$) of Togo?
Ensure brevity in your answer.  1.73e+06. In the year 1989, what is the difference between the Aid flow from UN agencies (US$) in Mauritius and Aid flow from UN agencies (US$) in Mozambique?
Make the answer very short. -2.29e+07. In the year 1989, what is the difference between the Aid flow from UN agencies (US$) of Mauritius and Aid flow from UN agencies (US$) of Togo?
Your answer should be very brief. -8.50e+05. In the year 1989, what is the difference between the Aid flow from UN agencies (US$) of Mozambique and Aid flow from UN agencies (US$) of Togo?
Give a very brief answer. 2.20e+07. In the year 1990, what is the difference between the Aid flow from UN agencies (US$) in Gambia, The and Aid flow from UN agencies (US$) in Mozambique?
Make the answer very short. -3.11e+07. In the year 1990, what is the difference between the Aid flow from UN agencies (US$) of Gambia, The and Aid flow from UN agencies (US$) of Togo?
Offer a terse response. 1.01e+06. In the year 1990, what is the difference between the Aid flow from UN agencies (US$) in Mauritius and Aid flow from UN agencies (US$) in Mozambique?
Give a very brief answer. -3.14e+07. In the year 1990, what is the difference between the Aid flow from UN agencies (US$) of Mauritius and Aid flow from UN agencies (US$) of Togo?
Offer a very short reply. 7.20e+05. In the year 1990, what is the difference between the Aid flow from UN agencies (US$) of Mozambique and Aid flow from UN agencies (US$) of Togo?
Ensure brevity in your answer.  3.21e+07. What is the ratio of the Aid flow from UN agencies (US$) of Gambia, The in 1983 to that in 1984?
Provide a short and direct response. 0.51. What is the ratio of the Aid flow from UN agencies (US$) in Mauritius in 1983 to that in 1984?
Offer a terse response. 0.89. What is the ratio of the Aid flow from UN agencies (US$) of Mozambique in 1983 to that in 1984?
Your answer should be compact. 0.64. What is the ratio of the Aid flow from UN agencies (US$) of Togo in 1983 to that in 1984?
Your answer should be compact. 1.14. What is the ratio of the Aid flow from UN agencies (US$) in Gambia, The in 1983 to that in 1985?
Make the answer very short. 0.7. What is the ratio of the Aid flow from UN agencies (US$) in Mauritius in 1983 to that in 1985?
Give a very brief answer. 2.62. What is the ratio of the Aid flow from UN agencies (US$) in Mozambique in 1983 to that in 1985?
Your response must be concise. 1.04. What is the ratio of the Aid flow from UN agencies (US$) in Togo in 1983 to that in 1985?
Your answer should be compact. 1.41. What is the ratio of the Aid flow from UN agencies (US$) of Gambia, The in 1983 to that in 1986?
Your answer should be very brief. 1.02. What is the ratio of the Aid flow from UN agencies (US$) of Mauritius in 1983 to that in 1986?
Provide a succinct answer. 2.32. What is the ratio of the Aid flow from UN agencies (US$) in Mozambique in 1983 to that in 1986?
Give a very brief answer. 1.32. What is the ratio of the Aid flow from UN agencies (US$) of Togo in 1983 to that in 1986?
Provide a short and direct response. 1.55. What is the ratio of the Aid flow from UN agencies (US$) of Gambia, The in 1983 to that in 1987?
Provide a short and direct response. 0.49. What is the ratio of the Aid flow from UN agencies (US$) in Mauritius in 1983 to that in 1987?
Provide a short and direct response. 4.73. What is the ratio of the Aid flow from UN agencies (US$) of Mozambique in 1983 to that in 1987?
Your response must be concise. 1.03. What is the ratio of the Aid flow from UN agencies (US$) in Togo in 1983 to that in 1987?
Offer a terse response. 1.54. What is the ratio of the Aid flow from UN agencies (US$) in Gambia, The in 1983 to that in 1988?
Your response must be concise. 0.62. What is the ratio of the Aid flow from UN agencies (US$) of Mauritius in 1983 to that in 1988?
Provide a succinct answer. 1.23. What is the ratio of the Aid flow from UN agencies (US$) of Mozambique in 1983 to that in 1988?
Offer a very short reply. 0.67. What is the ratio of the Aid flow from UN agencies (US$) of Togo in 1983 to that in 1988?
Your response must be concise. 1.12. What is the ratio of the Aid flow from UN agencies (US$) of Gambia, The in 1983 to that in 1989?
Your answer should be compact. 0.66. What is the ratio of the Aid flow from UN agencies (US$) in Mauritius in 1983 to that in 1989?
Provide a succinct answer. 1.92. What is the ratio of the Aid flow from UN agencies (US$) in Mozambique in 1983 to that in 1989?
Offer a terse response. 0.52. What is the ratio of the Aid flow from UN agencies (US$) in Togo in 1983 to that in 1989?
Your response must be concise. 1.15. What is the ratio of the Aid flow from UN agencies (US$) in Gambia, The in 1983 to that in 1990?
Provide a short and direct response. 0.91. What is the ratio of the Aid flow from UN agencies (US$) in Mozambique in 1983 to that in 1990?
Keep it short and to the point. 0.37. What is the ratio of the Aid flow from UN agencies (US$) in Togo in 1983 to that in 1990?
Keep it short and to the point. 1.39. What is the ratio of the Aid flow from UN agencies (US$) in Gambia, The in 1984 to that in 1985?
Offer a terse response. 1.38. What is the ratio of the Aid flow from UN agencies (US$) in Mauritius in 1984 to that in 1985?
Offer a very short reply. 2.93. What is the ratio of the Aid flow from UN agencies (US$) of Mozambique in 1984 to that in 1985?
Your answer should be compact. 1.63. What is the ratio of the Aid flow from UN agencies (US$) of Togo in 1984 to that in 1985?
Your answer should be compact. 1.24. What is the ratio of the Aid flow from UN agencies (US$) in Gambia, The in 1984 to that in 1986?
Give a very brief answer. 2.01. What is the ratio of the Aid flow from UN agencies (US$) of Mauritius in 1984 to that in 1986?
Offer a terse response. 2.59. What is the ratio of the Aid flow from UN agencies (US$) in Mozambique in 1984 to that in 1986?
Offer a very short reply. 2.07. What is the ratio of the Aid flow from UN agencies (US$) in Togo in 1984 to that in 1986?
Give a very brief answer. 1.36. What is the ratio of the Aid flow from UN agencies (US$) of Gambia, The in 1984 to that in 1987?
Give a very brief answer. 0.98. What is the ratio of the Aid flow from UN agencies (US$) of Mauritius in 1984 to that in 1987?
Provide a succinct answer. 5.29. What is the ratio of the Aid flow from UN agencies (US$) of Mozambique in 1984 to that in 1987?
Give a very brief answer. 1.62. What is the ratio of the Aid flow from UN agencies (US$) in Togo in 1984 to that in 1987?
Your answer should be compact. 1.35. What is the ratio of the Aid flow from UN agencies (US$) in Gambia, The in 1984 to that in 1988?
Keep it short and to the point. 1.22. What is the ratio of the Aid flow from UN agencies (US$) of Mauritius in 1984 to that in 1988?
Your answer should be very brief. 1.38. What is the ratio of the Aid flow from UN agencies (US$) of Mozambique in 1984 to that in 1988?
Provide a short and direct response. 1.06. What is the ratio of the Aid flow from UN agencies (US$) in Togo in 1984 to that in 1988?
Your answer should be very brief. 0.99. What is the ratio of the Aid flow from UN agencies (US$) in Gambia, The in 1984 to that in 1989?
Provide a succinct answer. 1.3. What is the ratio of the Aid flow from UN agencies (US$) in Mauritius in 1984 to that in 1989?
Give a very brief answer. 2.15. What is the ratio of the Aid flow from UN agencies (US$) of Mozambique in 1984 to that in 1989?
Provide a short and direct response. 0.81. What is the ratio of the Aid flow from UN agencies (US$) in Togo in 1984 to that in 1989?
Your answer should be very brief. 1.01. What is the ratio of the Aid flow from UN agencies (US$) in Gambia, The in 1984 to that in 1990?
Keep it short and to the point. 1.81. What is the ratio of the Aid flow from UN agencies (US$) in Mauritius in 1984 to that in 1990?
Give a very brief answer. 1.11. What is the ratio of the Aid flow from UN agencies (US$) in Mozambique in 1984 to that in 1990?
Keep it short and to the point. 0.58. What is the ratio of the Aid flow from UN agencies (US$) of Togo in 1984 to that in 1990?
Provide a succinct answer. 1.22. What is the ratio of the Aid flow from UN agencies (US$) of Gambia, The in 1985 to that in 1986?
Give a very brief answer. 1.46. What is the ratio of the Aid flow from UN agencies (US$) in Mauritius in 1985 to that in 1986?
Make the answer very short. 0.89. What is the ratio of the Aid flow from UN agencies (US$) of Mozambique in 1985 to that in 1986?
Your answer should be compact. 1.27. What is the ratio of the Aid flow from UN agencies (US$) of Togo in 1985 to that in 1986?
Give a very brief answer. 1.1. What is the ratio of the Aid flow from UN agencies (US$) in Gambia, The in 1985 to that in 1987?
Provide a succinct answer. 0.71. What is the ratio of the Aid flow from UN agencies (US$) of Mauritius in 1985 to that in 1987?
Give a very brief answer. 1.81. What is the ratio of the Aid flow from UN agencies (US$) in Mozambique in 1985 to that in 1987?
Provide a succinct answer. 1. What is the ratio of the Aid flow from UN agencies (US$) of Togo in 1985 to that in 1987?
Provide a short and direct response. 1.09. What is the ratio of the Aid flow from UN agencies (US$) in Gambia, The in 1985 to that in 1988?
Offer a terse response. 0.88. What is the ratio of the Aid flow from UN agencies (US$) of Mauritius in 1985 to that in 1988?
Keep it short and to the point. 0.47. What is the ratio of the Aid flow from UN agencies (US$) in Mozambique in 1985 to that in 1988?
Offer a very short reply. 0.65. What is the ratio of the Aid flow from UN agencies (US$) in Togo in 1985 to that in 1988?
Provide a succinct answer. 0.8. What is the ratio of the Aid flow from UN agencies (US$) of Gambia, The in 1985 to that in 1989?
Your answer should be compact. 0.94. What is the ratio of the Aid flow from UN agencies (US$) in Mauritius in 1985 to that in 1989?
Offer a very short reply. 0.73. What is the ratio of the Aid flow from UN agencies (US$) in Mozambique in 1985 to that in 1989?
Your answer should be compact. 0.5. What is the ratio of the Aid flow from UN agencies (US$) in Togo in 1985 to that in 1989?
Offer a terse response. 0.82. What is the ratio of the Aid flow from UN agencies (US$) of Gambia, The in 1985 to that in 1990?
Keep it short and to the point. 1.31. What is the ratio of the Aid flow from UN agencies (US$) in Mauritius in 1985 to that in 1990?
Your response must be concise. 0.38. What is the ratio of the Aid flow from UN agencies (US$) in Mozambique in 1985 to that in 1990?
Your answer should be very brief. 0.36. What is the ratio of the Aid flow from UN agencies (US$) of Togo in 1985 to that in 1990?
Offer a very short reply. 0.99. What is the ratio of the Aid flow from UN agencies (US$) of Gambia, The in 1986 to that in 1987?
Your response must be concise. 0.49. What is the ratio of the Aid flow from UN agencies (US$) in Mauritius in 1986 to that in 1987?
Offer a terse response. 2.04. What is the ratio of the Aid flow from UN agencies (US$) of Mozambique in 1986 to that in 1987?
Provide a short and direct response. 0.78. What is the ratio of the Aid flow from UN agencies (US$) of Gambia, The in 1986 to that in 1988?
Your response must be concise. 0.61. What is the ratio of the Aid flow from UN agencies (US$) of Mauritius in 1986 to that in 1988?
Your response must be concise. 0.53. What is the ratio of the Aid flow from UN agencies (US$) in Mozambique in 1986 to that in 1988?
Provide a succinct answer. 0.51. What is the ratio of the Aid flow from UN agencies (US$) of Togo in 1986 to that in 1988?
Provide a succinct answer. 0.72. What is the ratio of the Aid flow from UN agencies (US$) in Gambia, The in 1986 to that in 1989?
Your answer should be compact. 0.65. What is the ratio of the Aid flow from UN agencies (US$) in Mauritius in 1986 to that in 1989?
Offer a terse response. 0.83. What is the ratio of the Aid flow from UN agencies (US$) of Mozambique in 1986 to that in 1989?
Your response must be concise. 0.39. What is the ratio of the Aid flow from UN agencies (US$) in Togo in 1986 to that in 1989?
Offer a terse response. 0.74. What is the ratio of the Aid flow from UN agencies (US$) in Gambia, The in 1986 to that in 1990?
Make the answer very short. 0.9. What is the ratio of the Aid flow from UN agencies (US$) in Mauritius in 1986 to that in 1990?
Keep it short and to the point. 0.43. What is the ratio of the Aid flow from UN agencies (US$) of Mozambique in 1986 to that in 1990?
Keep it short and to the point. 0.28. What is the ratio of the Aid flow from UN agencies (US$) in Togo in 1986 to that in 1990?
Provide a succinct answer. 0.9. What is the ratio of the Aid flow from UN agencies (US$) of Gambia, The in 1987 to that in 1988?
Provide a short and direct response. 1.25. What is the ratio of the Aid flow from UN agencies (US$) of Mauritius in 1987 to that in 1988?
Keep it short and to the point. 0.26. What is the ratio of the Aid flow from UN agencies (US$) of Mozambique in 1987 to that in 1988?
Offer a terse response. 0.65. What is the ratio of the Aid flow from UN agencies (US$) of Togo in 1987 to that in 1988?
Offer a very short reply. 0.73. What is the ratio of the Aid flow from UN agencies (US$) in Gambia, The in 1987 to that in 1989?
Provide a succinct answer. 1.33. What is the ratio of the Aid flow from UN agencies (US$) of Mauritius in 1987 to that in 1989?
Make the answer very short. 0.41. What is the ratio of the Aid flow from UN agencies (US$) in Mozambique in 1987 to that in 1989?
Offer a very short reply. 0.5. What is the ratio of the Aid flow from UN agencies (US$) in Togo in 1987 to that in 1989?
Make the answer very short. 0.75. What is the ratio of the Aid flow from UN agencies (US$) in Gambia, The in 1987 to that in 1990?
Offer a terse response. 1.85. What is the ratio of the Aid flow from UN agencies (US$) of Mauritius in 1987 to that in 1990?
Give a very brief answer. 0.21. What is the ratio of the Aid flow from UN agencies (US$) of Mozambique in 1987 to that in 1990?
Provide a short and direct response. 0.36. What is the ratio of the Aid flow from UN agencies (US$) of Togo in 1987 to that in 1990?
Your response must be concise. 0.9. What is the ratio of the Aid flow from UN agencies (US$) in Gambia, The in 1988 to that in 1989?
Give a very brief answer. 1.06. What is the ratio of the Aid flow from UN agencies (US$) of Mauritius in 1988 to that in 1989?
Give a very brief answer. 1.56. What is the ratio of the Aid flow from UN agencies (US$) in Mozambique in 1988 to that in 1989?
Your response must be concise. 0.77. What is the ratio of the Aid flow from UN agencies (US$) of Togo in 1988 to that in 1989?
Make the answer very short. 1.02. What is the ratio of the Aid flow from UN agencies (US$) of Gambia, The in 1988 to that in 1990?
Give a very brief answer. 1.48. What is the ratio of the Aid flow from UN agencies (US$) in Mauritius in 1988 to that in 1990?
Ensure brevity in your answer.  0.81. What is the ratio of the Aid flow from UN agencies (US$) in Mozambique in 1988 to that in 1990?
Your answer should be compact. 0.55. What is the ratio of the Aid flow from UN agencies (US$) in Togo in 1988 to that in 1990?
Offer a terse response. 1.24. What is the ratio of the Aid flow from UN agencies (US$) in Gambia, The in 1989 to that in 1990?
Offer a very short reply. 1.39. What is the ratio of the Aid flow from UN agencies (US$) of Mauritius in 1989 to that in 1990?
Give a very brief answer. 0.52. What is the ratio of the Aid flow from UN agencies (US$) in Mozambique in 1989 to that in 1990?
Your answer should be very brief. 0.71. What is the ratio of the Aid flow from UN agencies (US$) in Togo in 1989 to that in 1990?
Your response must be concise. 1.21. What is the difference between the highest and the second highest Aid flow from UN agencies (US$) of Gambia, The?
Provide a succinct answer. 1.10e+05. What is the difference between the highest and the second highest Aid flow from UN agencies (US$) in Mozambique?
Make the answer very short. 9.74e+06. What is the difference between the highest and the second highest Aid flow from UN agencies (US$) of Togo?
Offer a terse response. 2.70e+05. What is the difference between the highest and the lowest Aid flow from UN agencies (US$) in Gambia, The?
Provide a succinct answer. 2.63e+06. What is the difference between the highest and the lowest Aid flow from UN agencies (US$) in Mauritius?
Offer a terse response. 2.23e+06. What is the difference between the highest and the lowest Aid flow from UN agencies (US$) of Mozambique?
Provide a succinct answer. 2.44e+07. What is the difference between the highest and the lowest Aid flow from UN agencies (US$) in Togo?
Offer a very short reply. 8.70e+05. 